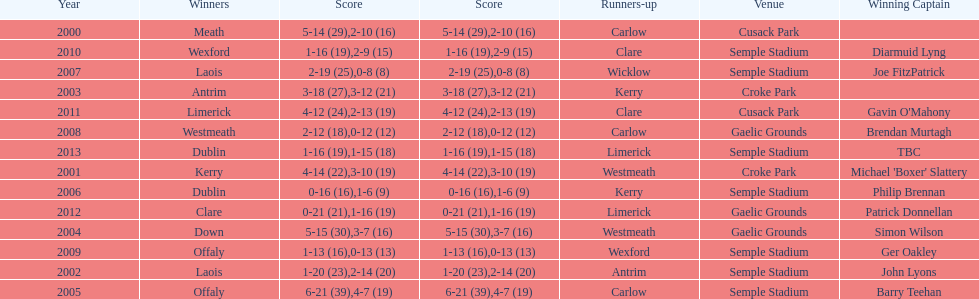How many winners won in semple stadium? 7. 